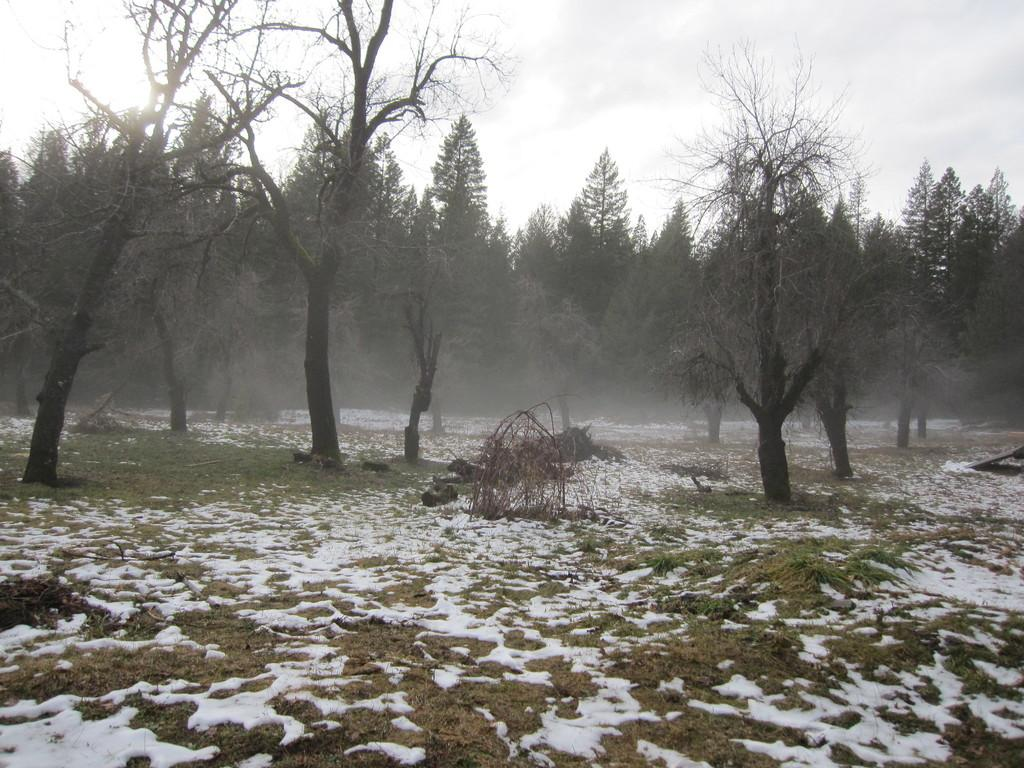What type of terrain is visible in the image? The ground is visible in the image, and there is grass present. What is the weather condition in the image? There is snow in the image, indicating a cold or wintery condition. What types of trees can be seen in the image? There are green trees and black trees in the image. What is visible in the background of the image? The sky is visible in the background of the image. What position does the pet hold in the image? There is no pet present in the image. How does the drain affect the snow in the image? There is no drain present in the image, so its effect on the snow cannot be determined. 